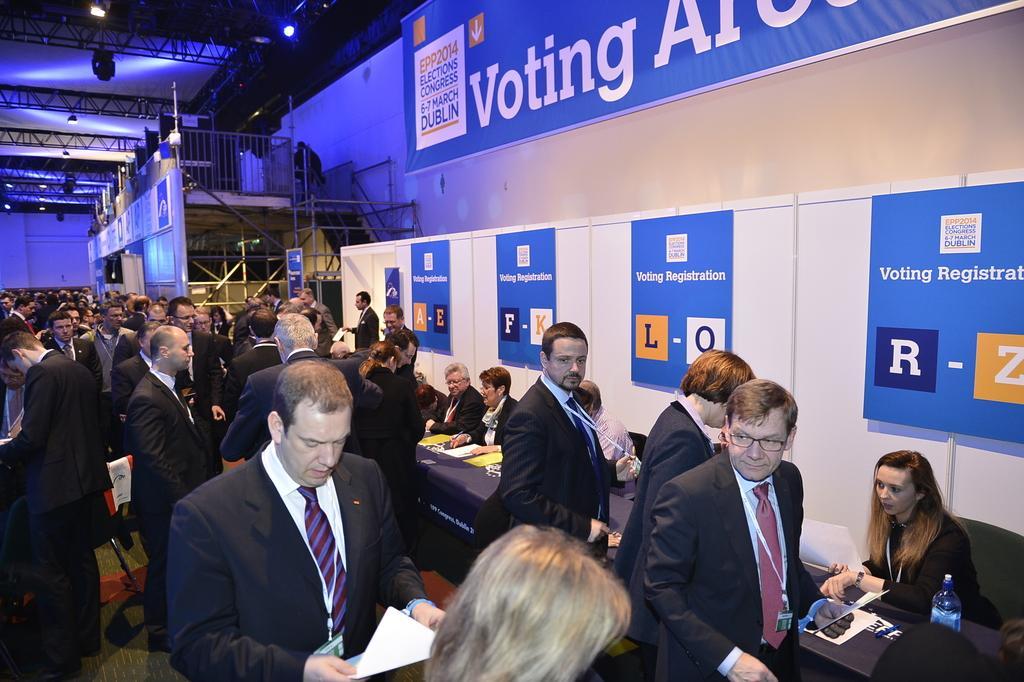Describe this image in one or two sentences. This image is taken indoors. In the background there is a wall with a few boards with text on them and there is a staircase without railing. At the top of the image there is a roof with lamps and iron bars. In the middle of the image many people are standing on the floor and a few are sitting on the chairs and there is a table with many things on it. 